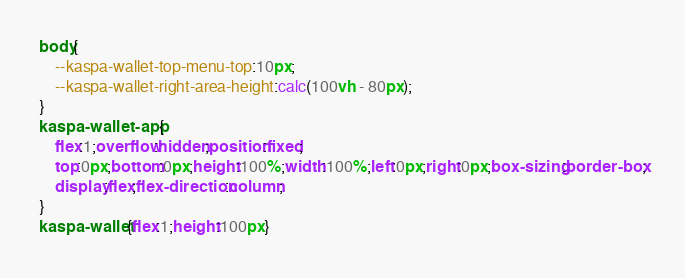Convert code to text. <code><loc_0><loc_0><loc_500><loc_500><_CSS_>body{
	--kaspa-wallet-top-menu-top:10px;
	--kaspa-wallet-right-area-height:calc(100vh - 80px);
}
kaspa-wallet-app{
	flex:1;overflow:hidden;position:fixed;
	top:0px;bottom:0px;height:100%;width:100%;left:0px;right:0px;box-sizing:border-box;
	display:flex;flex-direction:column;
}
kaspa-wallet{flex:1;height:100px}</code> 